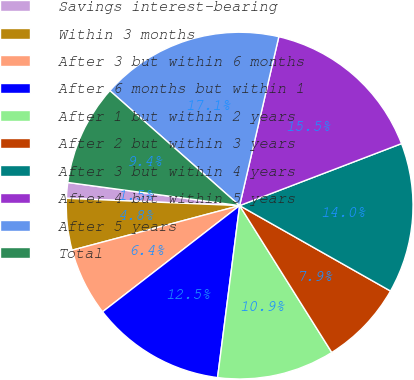<chart> <loc_0><loc_0><loc_500><loc_500><pie_chart><fcel>Savings interest-bearing<fcel>Within 3 months<fcel>After 3 but within 6 months<fcel>After 6 months but within 1<fcel>After 1 but within 2 years<fcel>After 2 but within 3 years<fcel>After 3 but within 4 years<fcel>After 4 but within 5 years<fcel>After 5 years<fcel>Total<nl><fcel>1.46%<fcel>4.81%<fcel>6.35%<fcel>12.48%<fcel>10.95%<fcel>7.88%<fcel>14.02%<fcel>15.55%<fcel>17.09%<fcel>9.41%<nl></chart> 